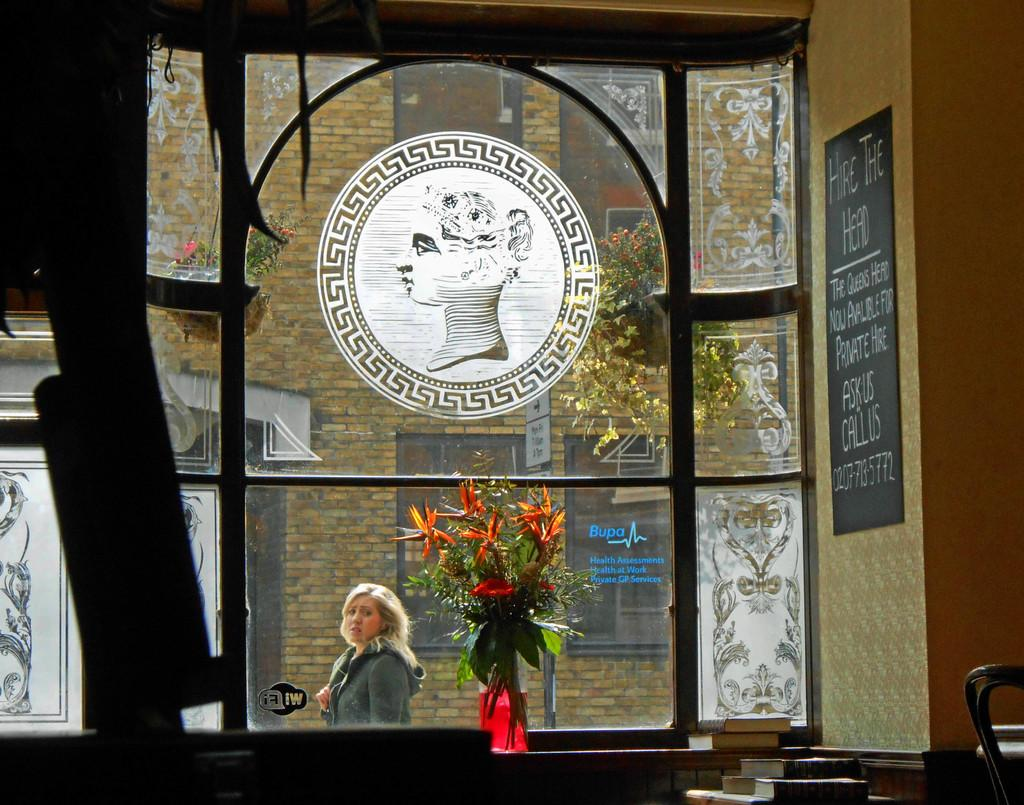<image>
Share a concise interpretation of the image provided. Person standing in front of a window that says BUPA on it. 